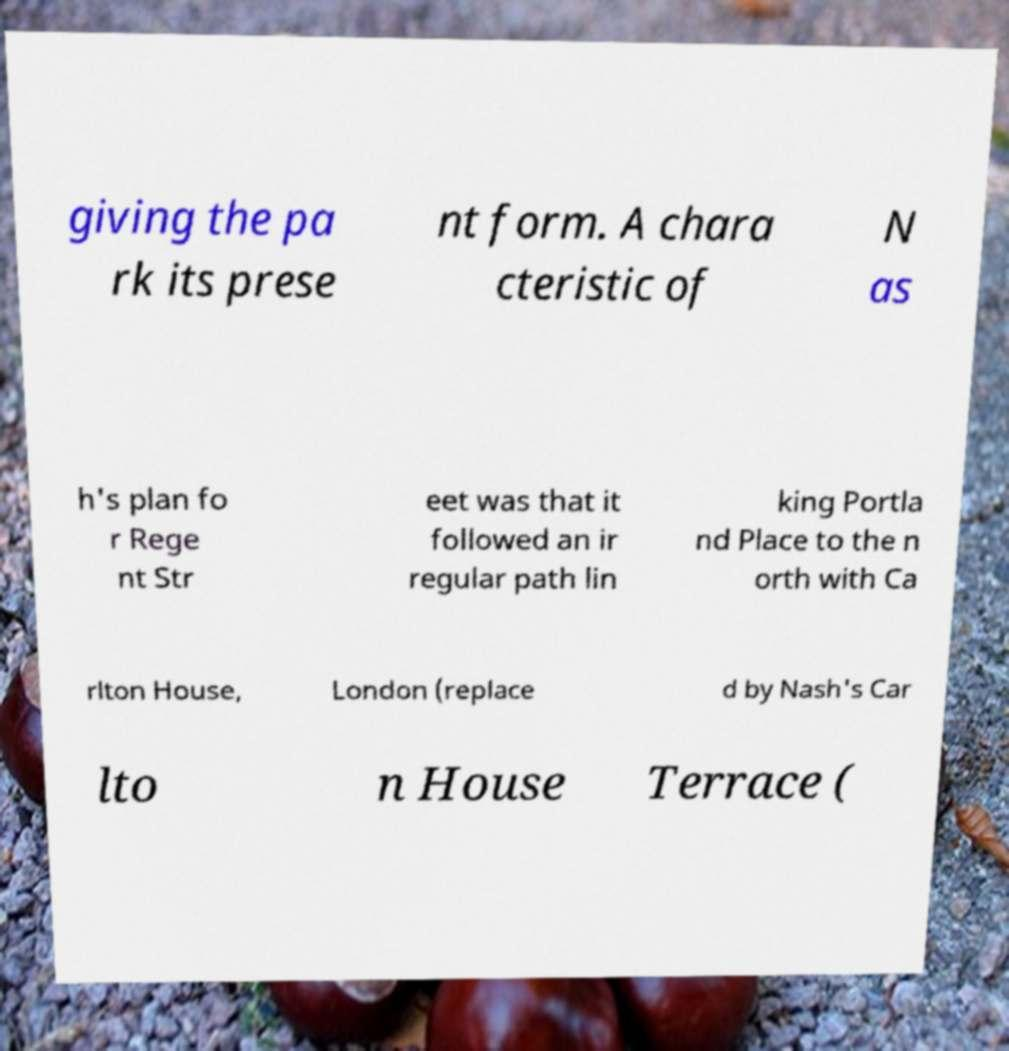Can you accurately transcribe the text from the provided image for me? giving the pa rk its prese nt form. A chara cteristic of N as h's plan fo r Rege nt Str eet was that it followed an ir regular path lin king Portla nd Place to the n orth with Ca rlton House, London (replace d by Nash's Car lto n House Terrace ( 